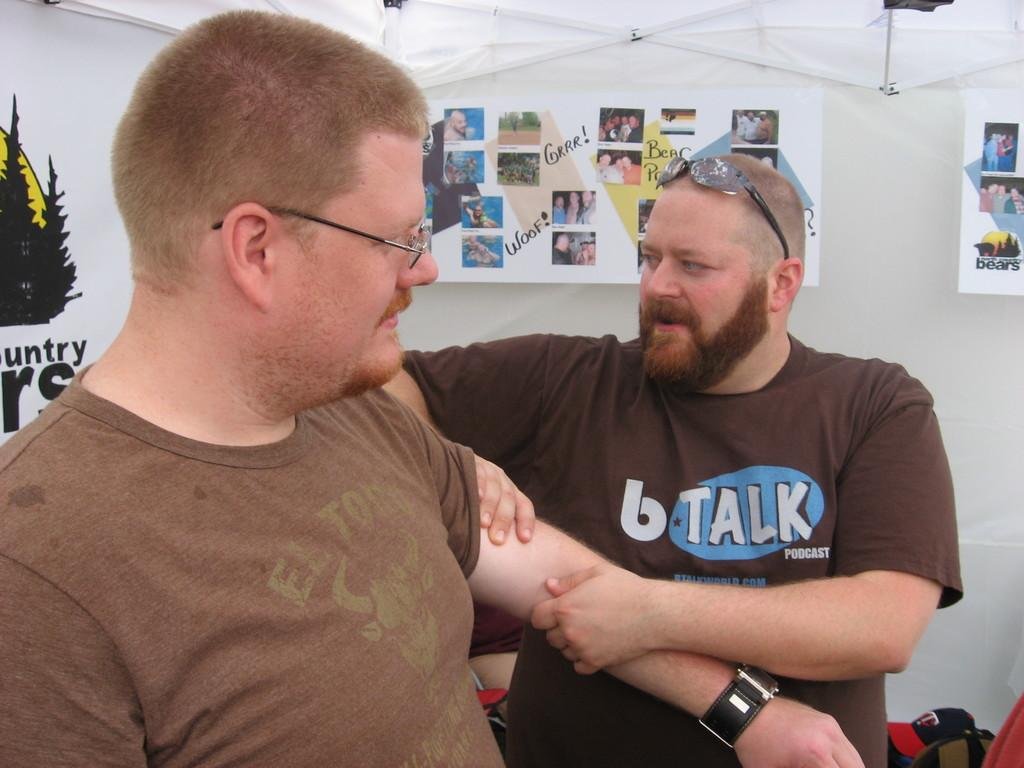How many people are present in the image? There are two people standing in the image. What can be seen on the wall in the image? There is a wall with posters on it. What type of clothing accessory is visible in the image? There is a cap visible in the image. What part of a building can be seen in the image? The roof is visible in the image. Can you describe the haircut of the person giving a teaching lesson in the image? There is no person giving a teaching lesson in the image, nor is there any indication of a haircut. 